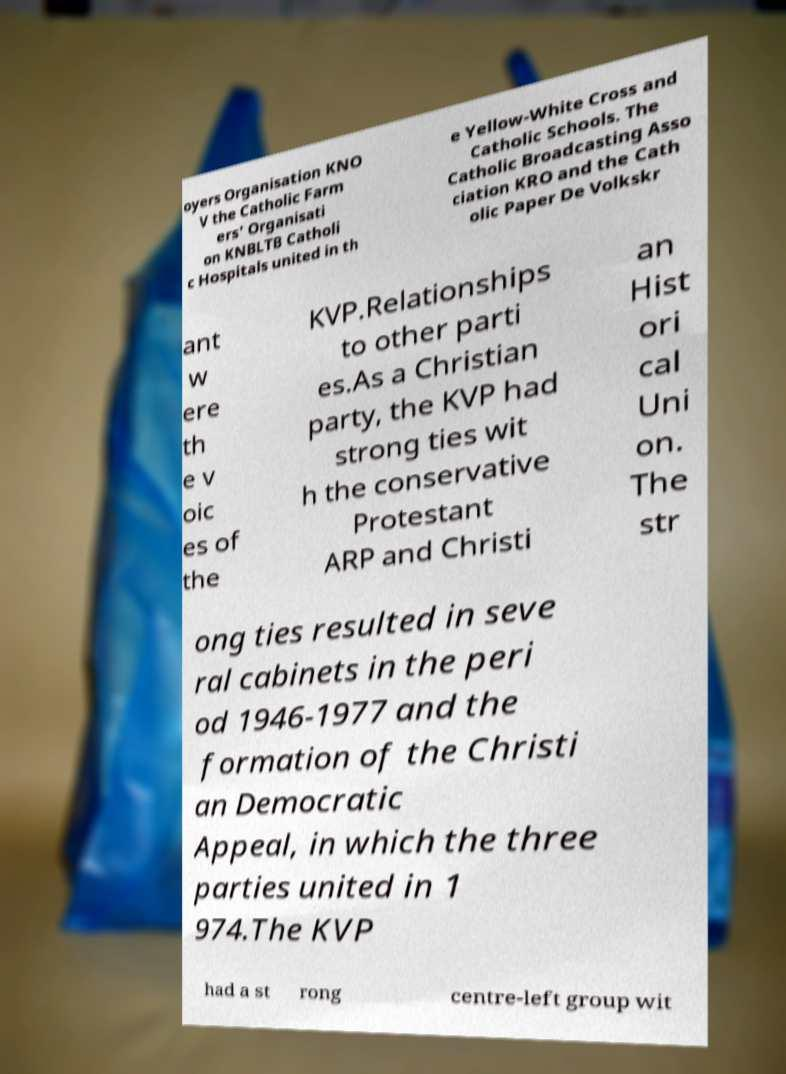For documentation purposes, I need the text within this image transcribed. Could you provide that? oyers Organisation KNO V the Catholic Farm ers' Organisati on KNBLTB Catholi c Hospitals united in th e Yellow-White Cross and Catholic Schools. The Catholic Broadcasting Asso ciation KRO and the Cath olic Paper De Volkskr ant w ere th e v oic es of the KVP.Relationships to other parti es.As a Christian party, the KVP had strong ties wit h the conservative Protestant ARP and Christi an Hist ori cal Uni on. The str ong ties resulted in seve ral cabinets in the peri od 1946-1977 and the formation of the Christi an Democratic Appeal, in which the three parties united in 1 974.The KVP had a st rong centre-left group wit 